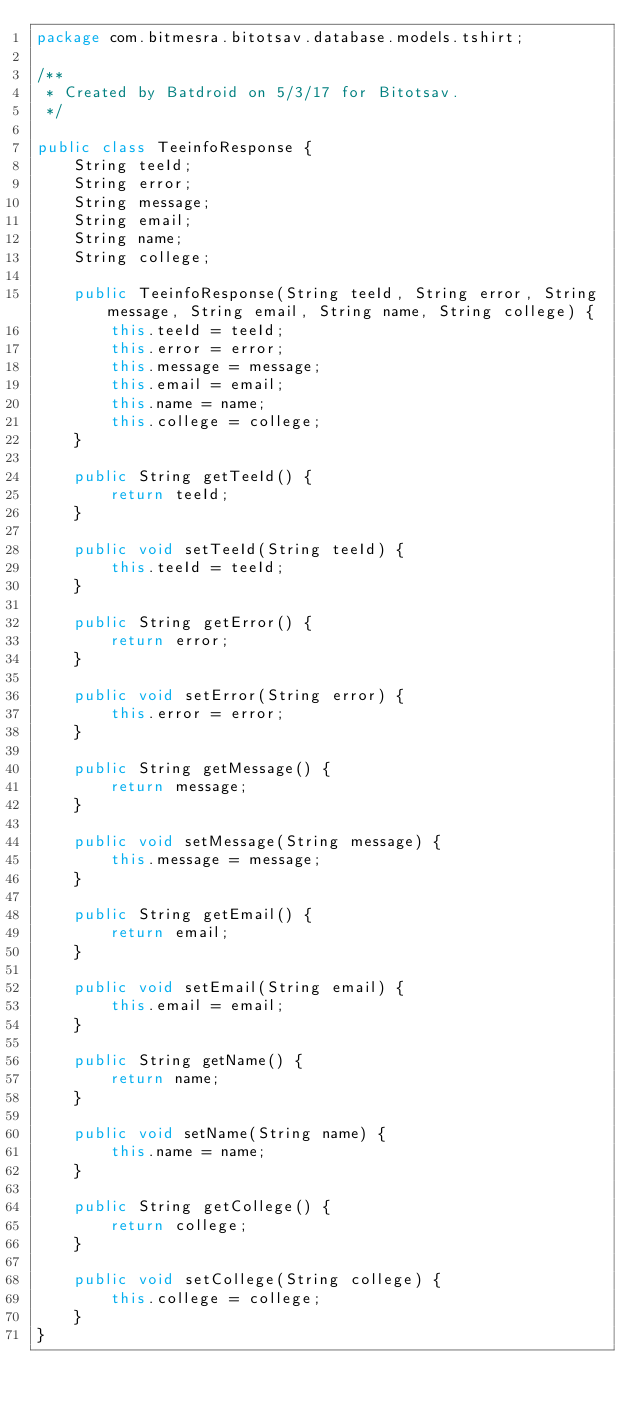Convert code to text. <code><loc_0><loc_0><loc_500><loc_500><_Java_>package com.bitmesra.bitotsav.database.models.tshirt;

/**
 * Created by Batdroid on 5/3/17 for Bitotsav.
 */

public class TeeinfoResponse {
    String teeId;
    String error;
    String message;
    String email;
    String name;
    String college;

    public TeeinfoResponse(String teeId, String error, String message, String email, String name, String college) {
        this.teeId = teeId;
        this.error = error;
        this.message = message;
        this.email = email;
        this.name = name;
        this.college = college;
    }

    public String getTeeId() {
        return teeId;
    }

    public void setTeeId(String teeId) {
        this.teeId = teeId;
    }

    public String getError() {
        return error;
    }

    public void setError(String error) {
        this.error = error;
    }

    public String getMessage() {
        return message;
    }

    public void setMessage(String message) {
        this.message = message;
    }

    public String getEmail() {
        return email;
    }

    public void setEmail(String email) {
        this.email = email;
    }

    public String getName() {
        return name;
    }

    public void setName(String name) {
        this.name = name;
    }

    public String getCollege() {
        return college;
    }

    public void setCollege(String college) {
        this.college = college;
    }
}
</code> 